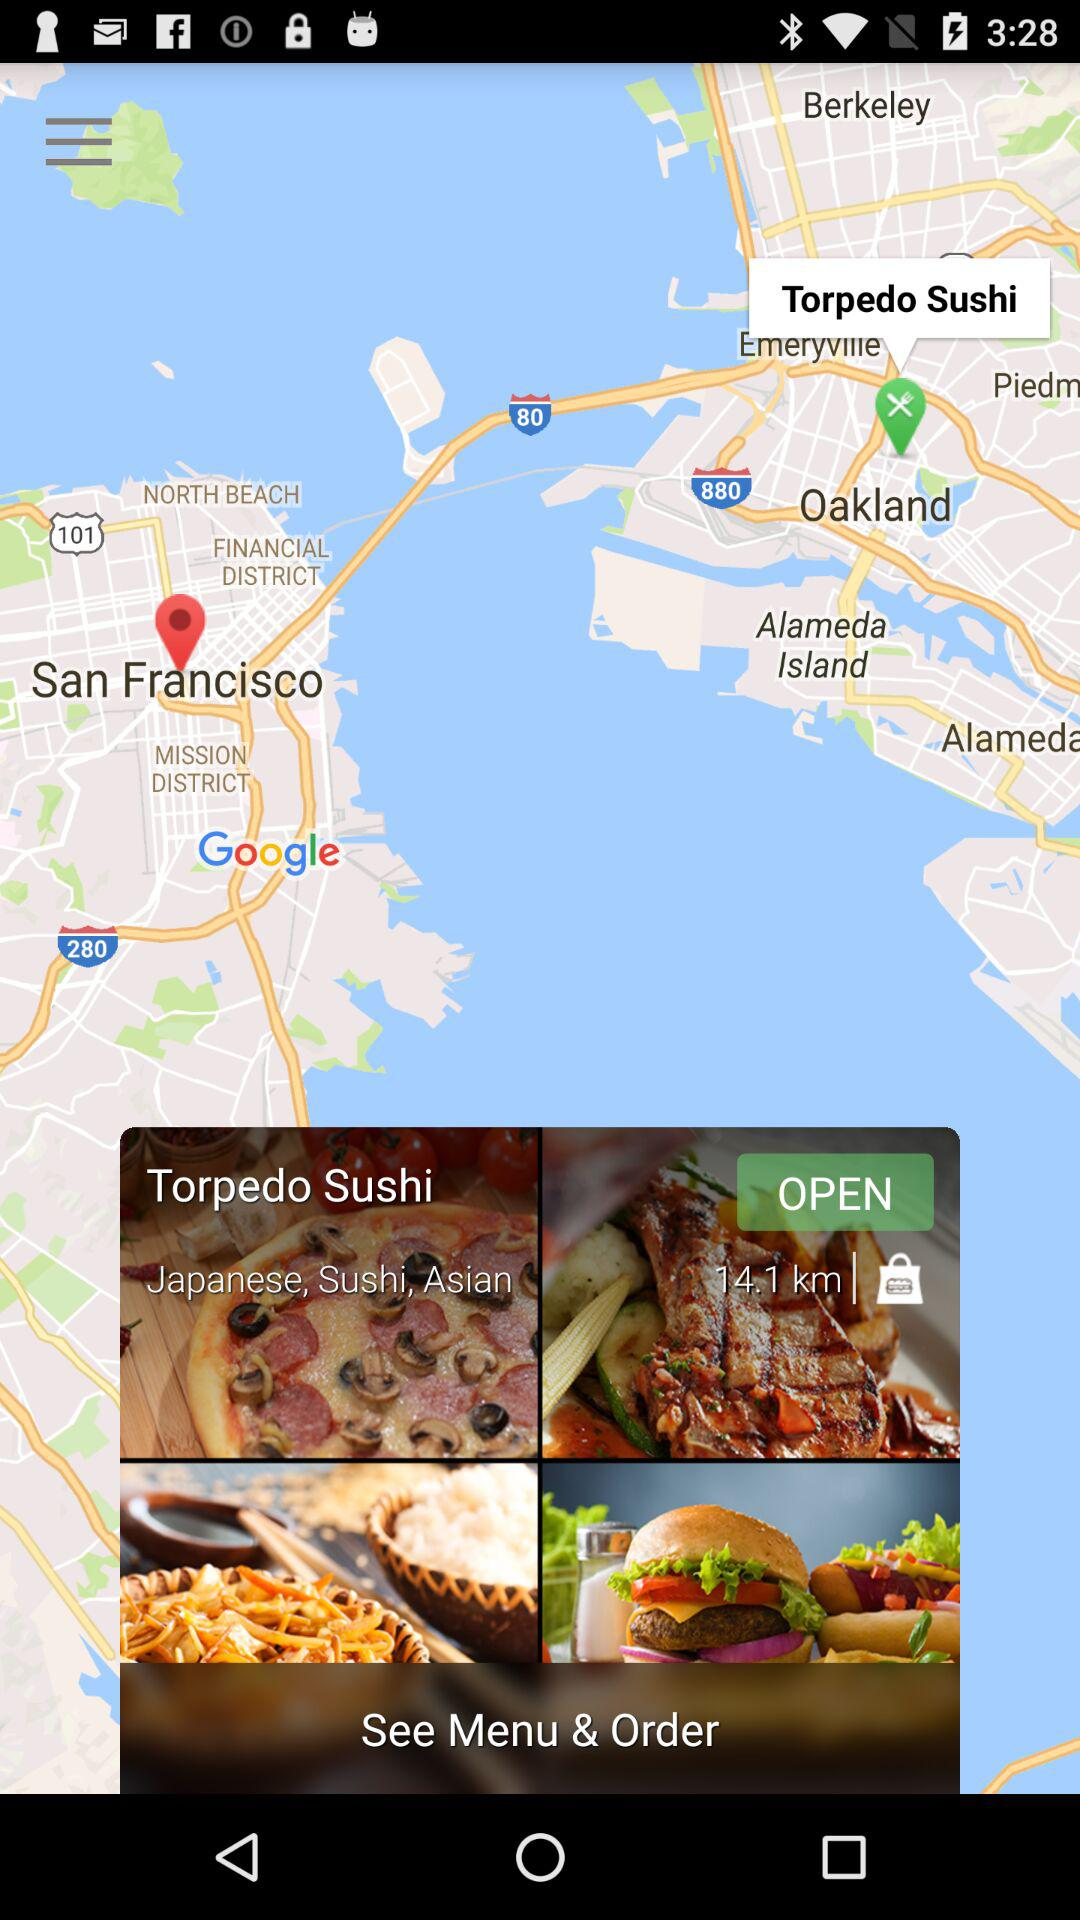How far away is the restaurant?
Answer the question using a single word or phrase. 14.1 km 